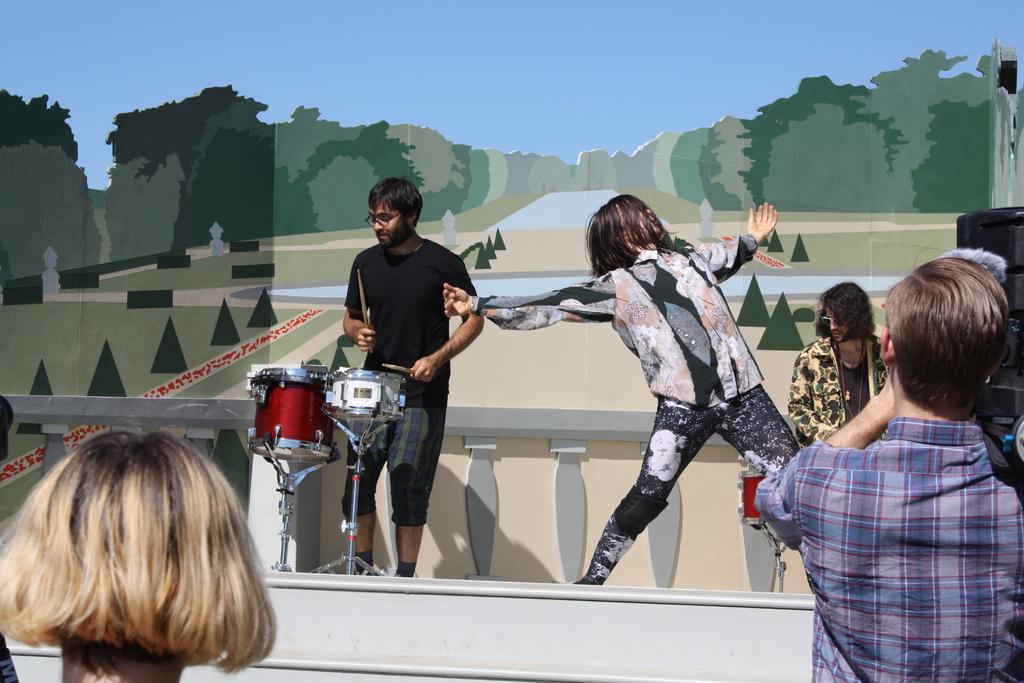Describe this image in one or two sentences. In the image we can see there are people standing and one is sitting. They are wearing clothes. Here we can see musical instruments and drumsticks. Here we can see a poster and a video camera. 